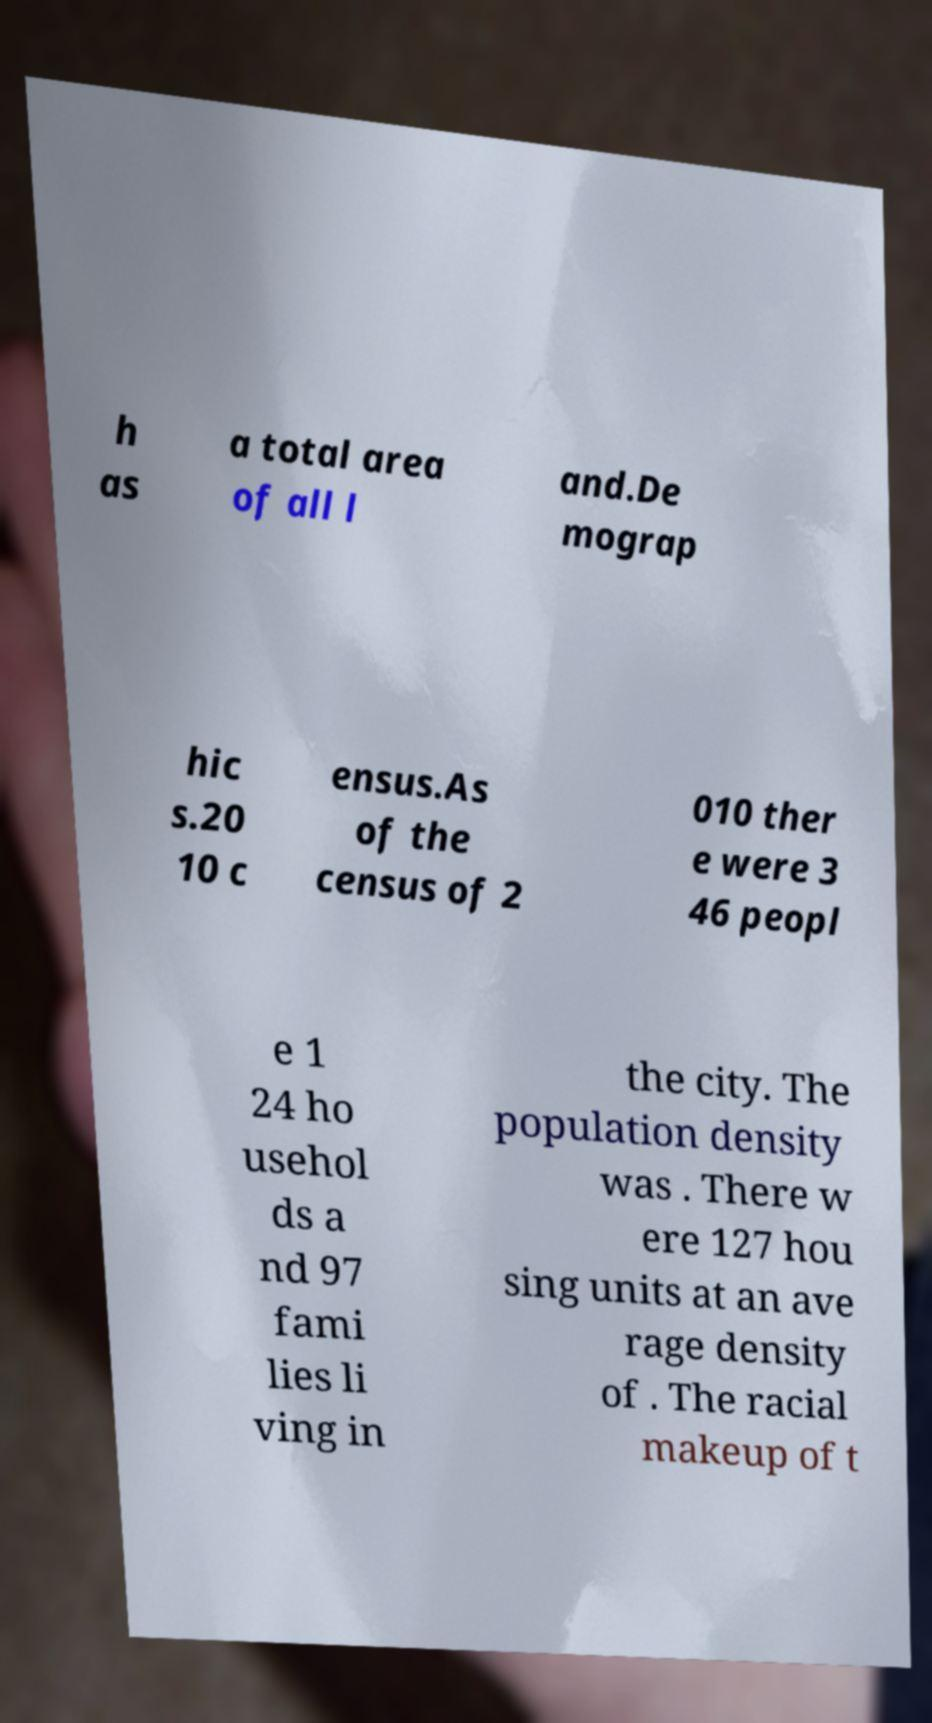There's text embedded in this image that I need extracted. Can you transcribe it verbatim? h as a total area of all l and.De mograp hic s.20 10 c ensus.As of the census of 2 010 ther e were 3 46 peopl e 1 24 ho usehol ds a nd 97 fami lies li ving in the city. The population density was . There w ere 127 hou sing units at an ave rage density of . The racial makeup of t 